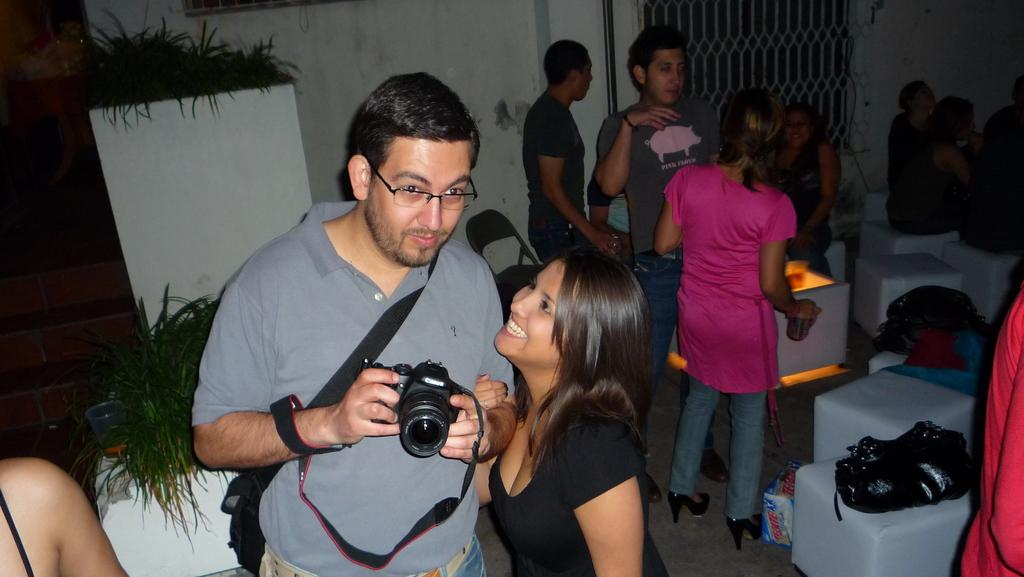Who is present in the image? There is a woman in the image. What is the woman doing? The woman is smiling. What objects can be seen in the image? There are flower pots and a bowl in the image. How many people are in the image? There are people in the image, including the woman. What can be seen in the background of the image? There is a wall and a fencing gate in the background of the image. What type of dinosaurs can be seen in the image? There are no dinosaurs present in the image. What type of substance is being sold at the airport in the image? There is no airport or substance being sold in the image. 